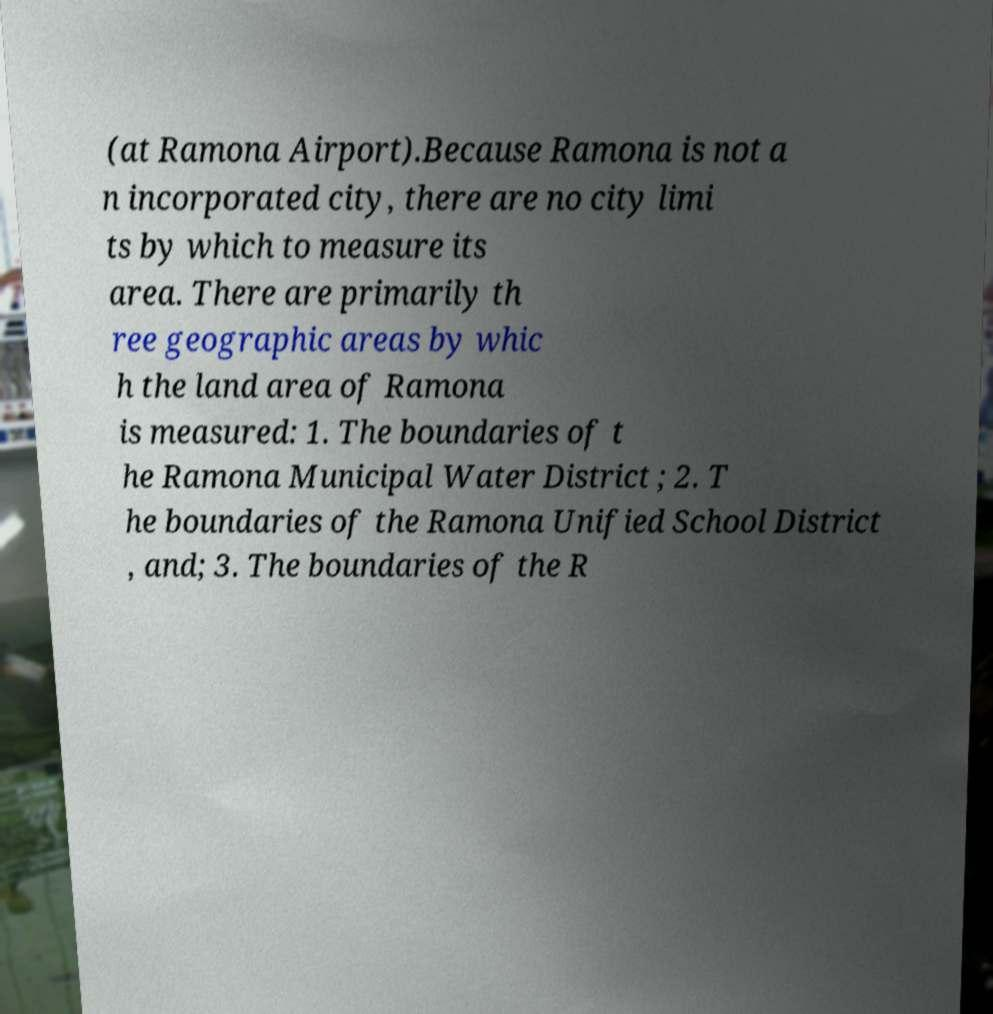Please identify and transcribe the text found in this image. (at Ramona Airport).Because Ramona is not a n incorporated city, there are no city limi ts by which to measure its area. There are primarily th ree geographic areas by whic h the land area of Ramona is measured: 1. The boundaries of t he Ramona Municipal Water District ; 2. T he boundaries of the Ramona Unified School District , and; 3. The boundaries of the R 